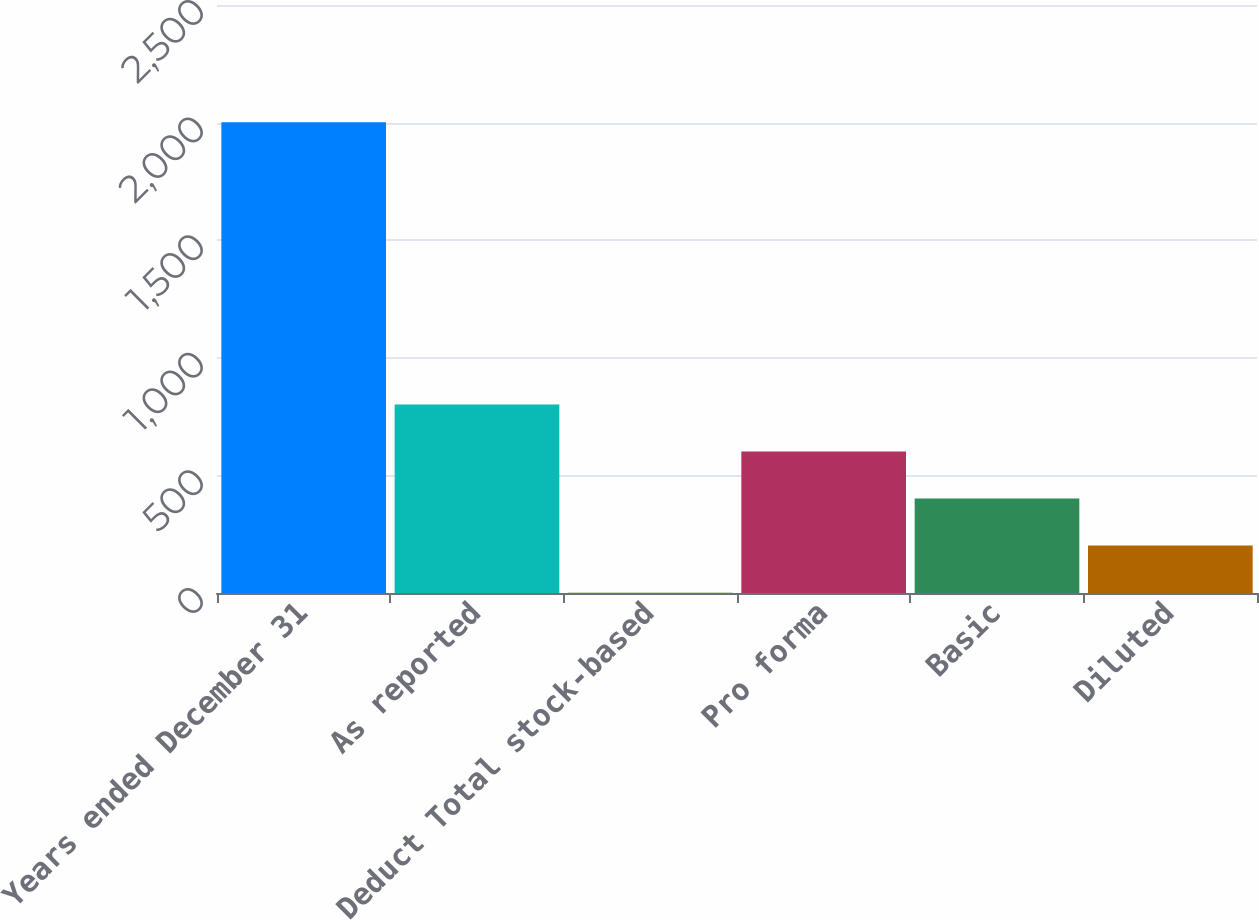Convert chart to OTSL. <chart><loc_0><loc_0><loc_500><loc_500><bar_chart><fcel>Years ended December 31<fcel>As reported<fcel>Deduct Total stock-based<fcel>Pro forma<fcel>Basic<fcel>Diluted<nl><fcel>2002<fcel>801.76<fcel>1.6<fcel>601.72<fcel>401.68<fcel>201.64<nl></chart> 